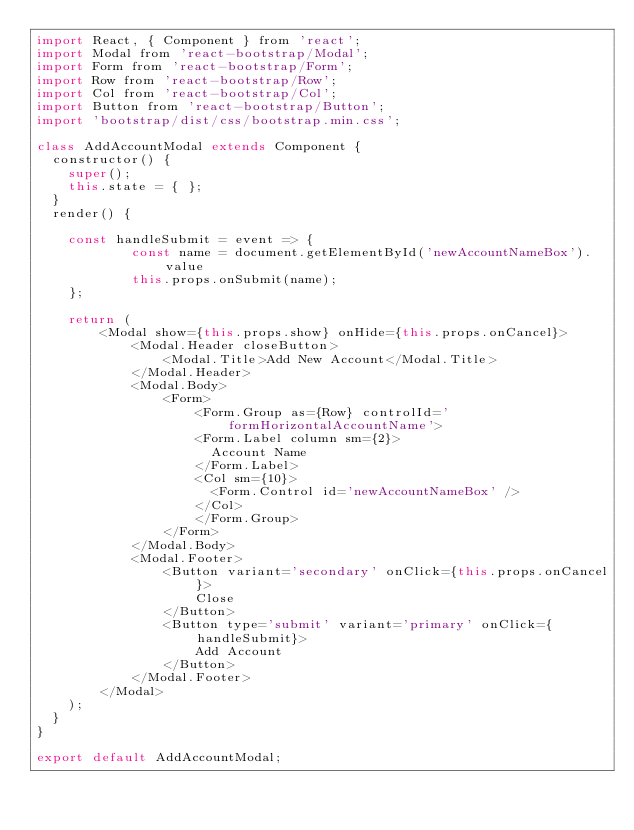Convert code to text. <code><loc_0><loc_0><loc_500><loc_500><_JavaScript_>import React, { Component } from 'react';
import Modal from 'react-bootstrap/Modal';
import Form from 'react-bootstrap/Form';
import Row from 'react-bootstrap/Row';
import Col from 'react-bootstrap/Col';
import Button from 'react-bootstrap/Button';
import 'bootstrap/dist/css/bootstrap.min.css';

class AddAccountModal extends Component {
  constructor() {
    super();
    this.state = { };
  }
  render() {
	  
	const handleSubmit = event => {
			const name = document.getElementById('newAccountNameBox').value
			this.props.onSubmit(name);
	};
	
    return (
		<Modal show={this.props.show} onHide={this.props.onCancel}>
			<Modal.Header closeButton>
				<Modal.Title>Add New Account</Modal.Title>
			</Modal.Header>
			<Modal.Body>
				<Form>
					<Form.Group as={Row} controlId='formHorizontalAccountName'>
					<Form.Label column sm={2}>
					  Account Name
					</Form.Label>
					<Col sm={10}>
					  <Form.Control id='newAccountNameBox' />
					</Col>
					</Form.Group>
				</Form>
			</Modal.Body>
			<Modal.Footer>
				<Button variant='secondary' onClick={this.props.onCancel}>
					Close
				</Button>
				<Button type='submit' variant='primary' onClick={handleSubmit}>
					Add Account
				</Button>
			</Modal.Footer>
		</Modal>
    );
  }
}

export default AddAccountModal;



</code> 